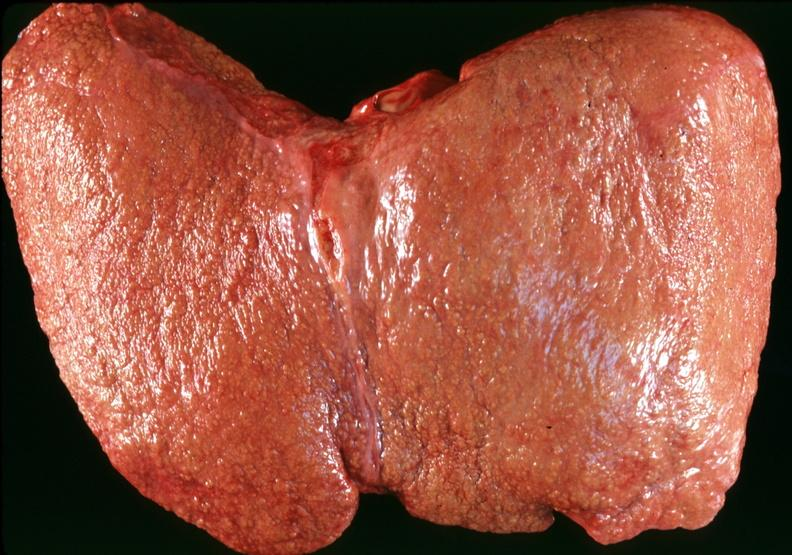what does this image show?
Answer the question using a single word or phrase. Cirrhosis 